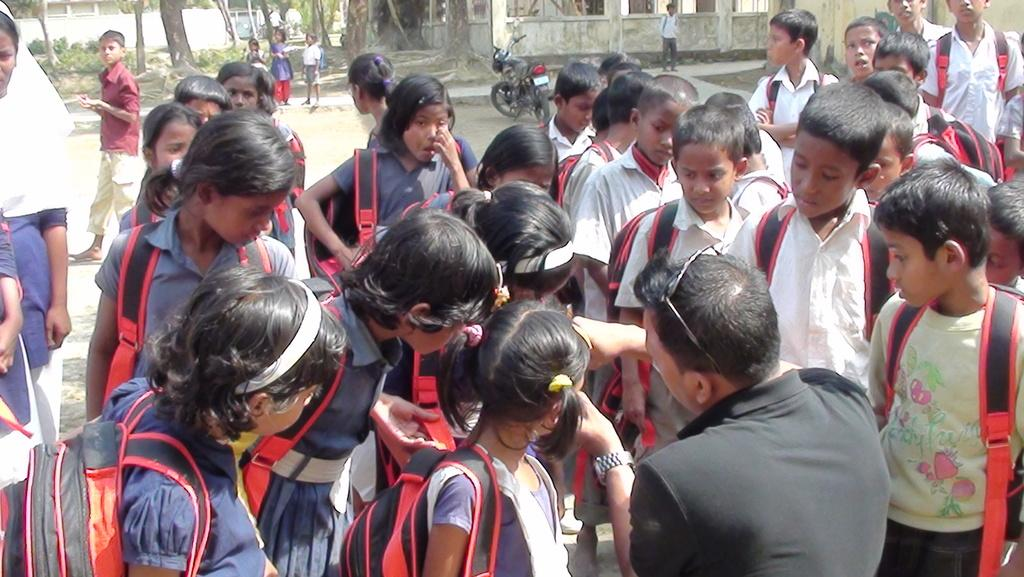How many people are in the image? There is a group of people in the image, but the exact number cannot be determined from the provided facts. What can be seen in the background of the image? There are trees, buildings, and a vehicle in the background of the image. What color is the sail on the eye in the image? There is no sail or eye present in the image; it features a group of people with a background containing trees, buildings, and a vehicle. 